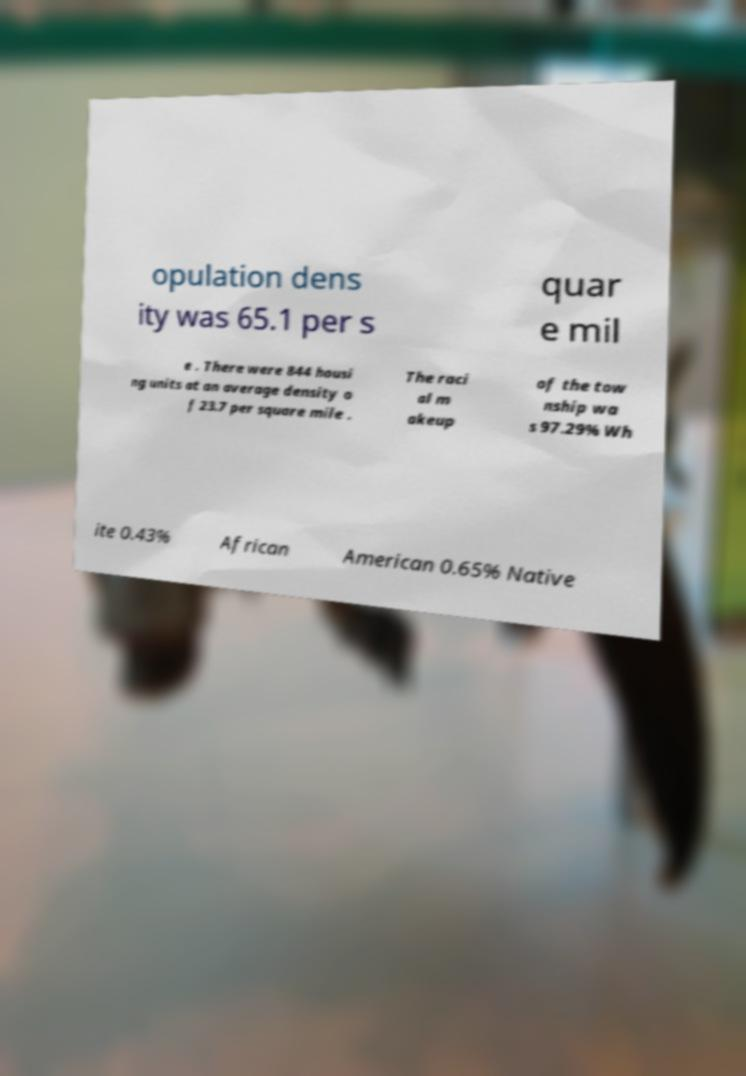Can you accurately transcribe the text from the provided image for me? opulation dens ity was 65.1 per s quar e mil e . There were 844 housi ng units at an average density o f 23.7 per square mile . The raci al m akeup of the tow nship wa s 97.29% Wh ite 0.43% African American 0.65% Native 